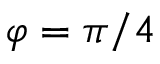<formula> <loc_0><loc_0><loc_500><loc_500>\varphi = \pi / 4</formula> 